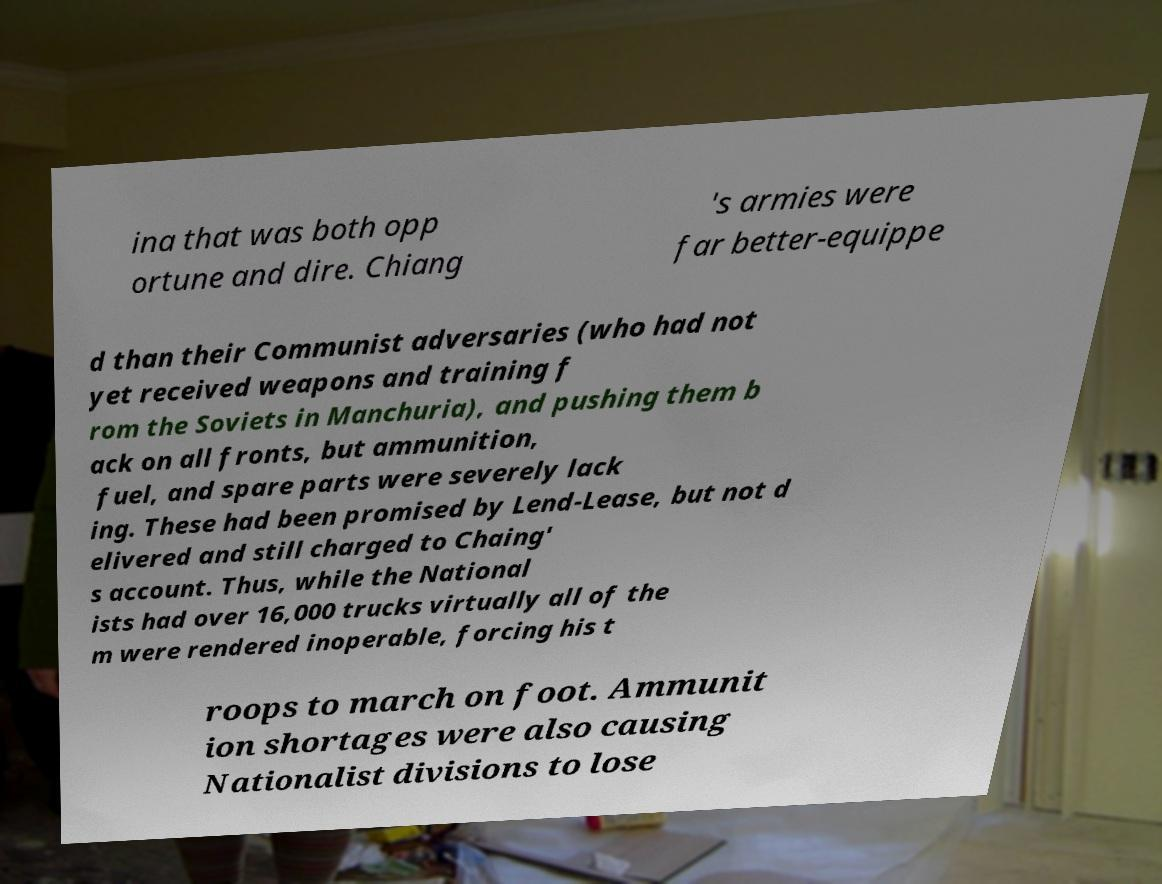Could you assist in decoding the text presented in this image and type it out clearly? ina that was both opp ortune and dire. Chiang 's armies were far better-equippe d than their Communist adversaries (who had not yet received weapons and training f rom the Soviets in Manchuria), and pushing them b ack on all fronts, but ammunition, fuel, and spare parts were severely lack ing. These had been promised by Lend-Lease, but not d elivered and still charged to Chaing' s account. Thus, while the National ists had over 16,000 trucks virtually all of the m were rendered inoperable, forcing his t roops to march on foot. Ammunit ion shortages were also causing Nationalist divisions to lose 